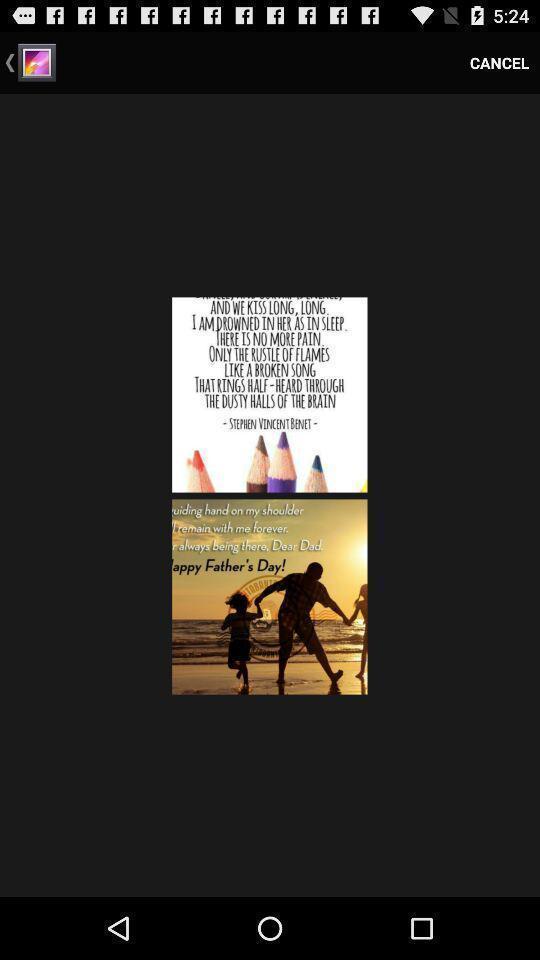Describe the visual elements of this screenshot. Screen shows images of quotes. 